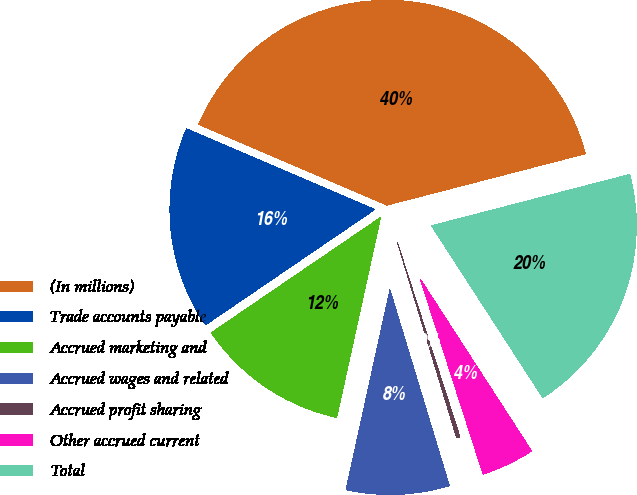Convert chart to OTSL. <chart><loc_0><loc_0><loc_500><loc_500><pie_chart><fcel>(In millions)<fcel>Trade accounts payable<fcel>Accrued marketing and<fcel>Accrued wages and related<fcel>Accrued profit sharing<fcel>Other accrued current<fcel>Total<nl><fcel>39.52%<fcel>15.97%<fcel>12.04%<fcel>8.12%<fcel>0.27%<fcel>4.19%<fcel>19.89%<nl></chart> 